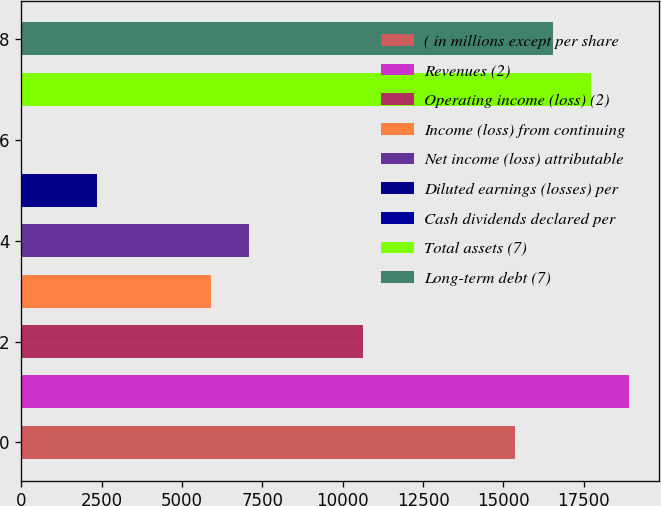<chart> <loc_0><loc_0><loc_500><loc_500><bar_chart><fcel>( in millions except per share<fcel>Revenues (2)<fcel>Operating income (loss) (2)<fcel>Income (loss) from continuing<fcel>Net income (loss) attributable<fcel>Diluted earnings (losses) per<fcel>Cash dividends declared per<fcel>Total assets (7)<fcel>Long-term debt (7)<nl><fcel>15358<fcel>18902.1<fcel>10632.6<fcel>5907.24<fcel>7088.59<fcel>2363.19<fcel>0.49<fcel>17720.7<fcel>16539.4<nl></chart> 